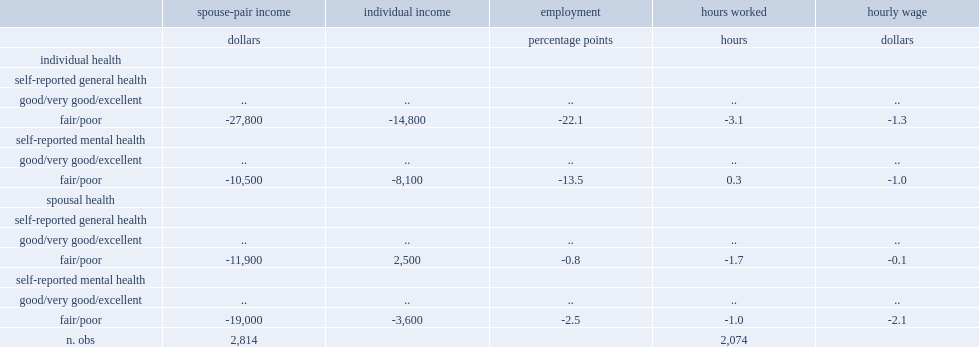What was the number difference between women with poor general health and women with good general health in spouse-pair income? -27800.0. What was the percent difference between women having poor health and those with good to excellent general health? -22.1. 